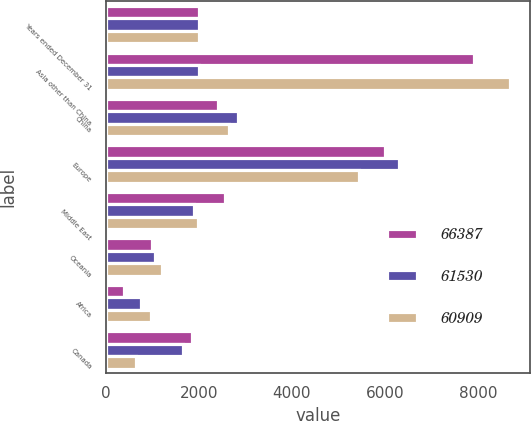<chart> <loc_0><loc_0><loc_500><loc_500><stacked_bar_chart><ecel><fcel>Years ended December 31<fcel>Asia other than China<fcel>China<fcel>Europe<fcel>Middle East<fcel>Oceania<fcel>Africa<fcel>Canada<nl><fcel>66387<fcel>2008<fcel>7913<fcel>2404<fcel>5992<fcel>2568<fcel>989<fcel>406<fcel>1849<nl><fcel>61530<fcel>2007<fcel>2006<fcel>2853<fcel>6296<fcel>1891<fcel>1057<fcel>751<fcel>1653<nl><fcel>60909<fcel>2006<fcel>8672<fcel>2659<fcel>5445<fcel>1991<fcel>1206<fcel>967<fcel>660<nl></chart> 